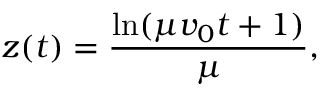Convert formula to latex. <formula><loc_0><loc_0><loc_500><loc_500>z ( t ) = \frac { \ln ( \mu v _ { 0 } t + 1 ) } { \mu } ,</formula> 